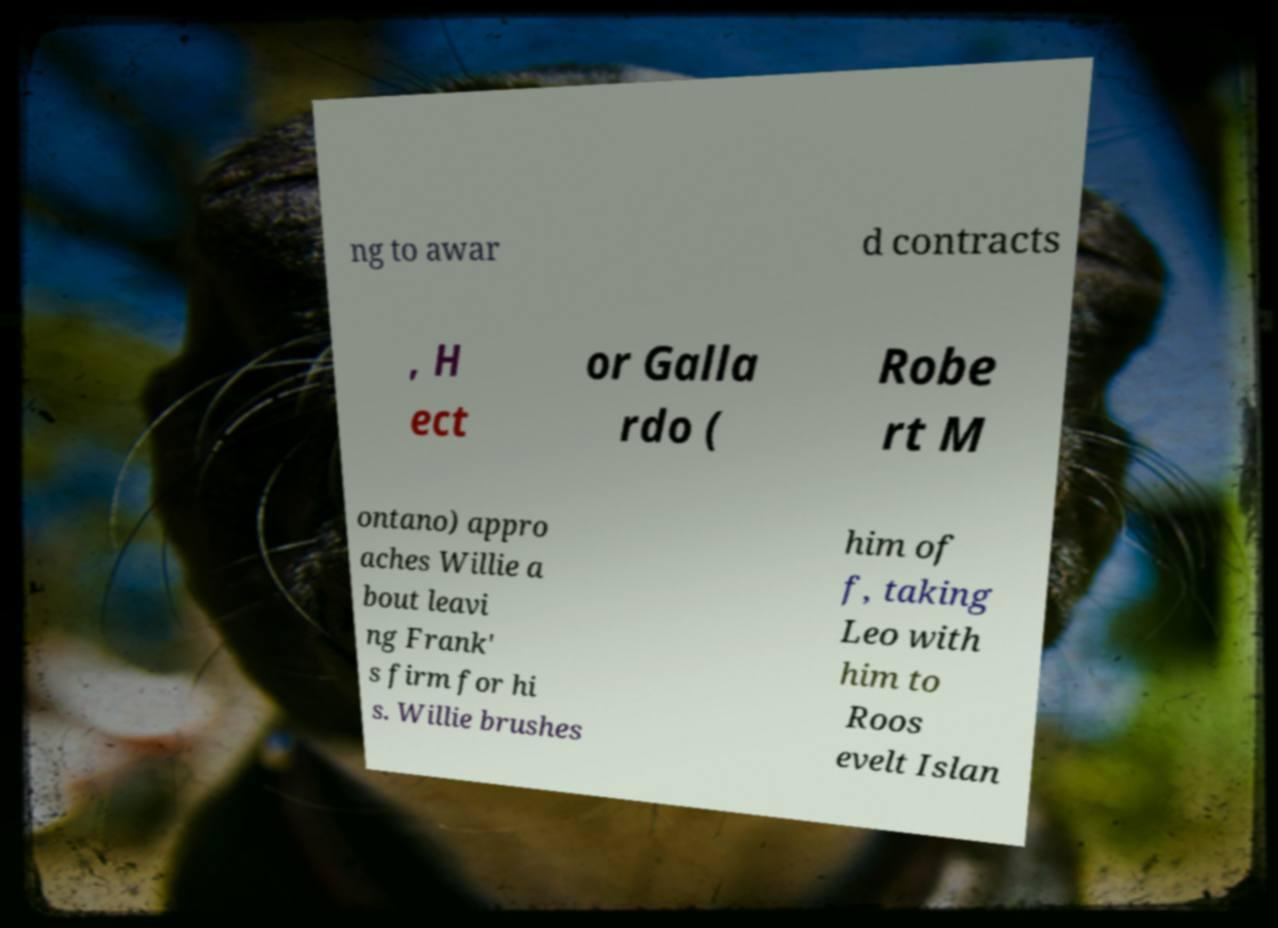Could you extract and type out the text from this image? ng to awar d contracts , H ect or Galla rdo ( Robe rt M ontano) appro aches Willie a bout leavi ng Frank' s firm for hi s. Willie brushes him of f, taking Leo with him to Roos evelt Islan 